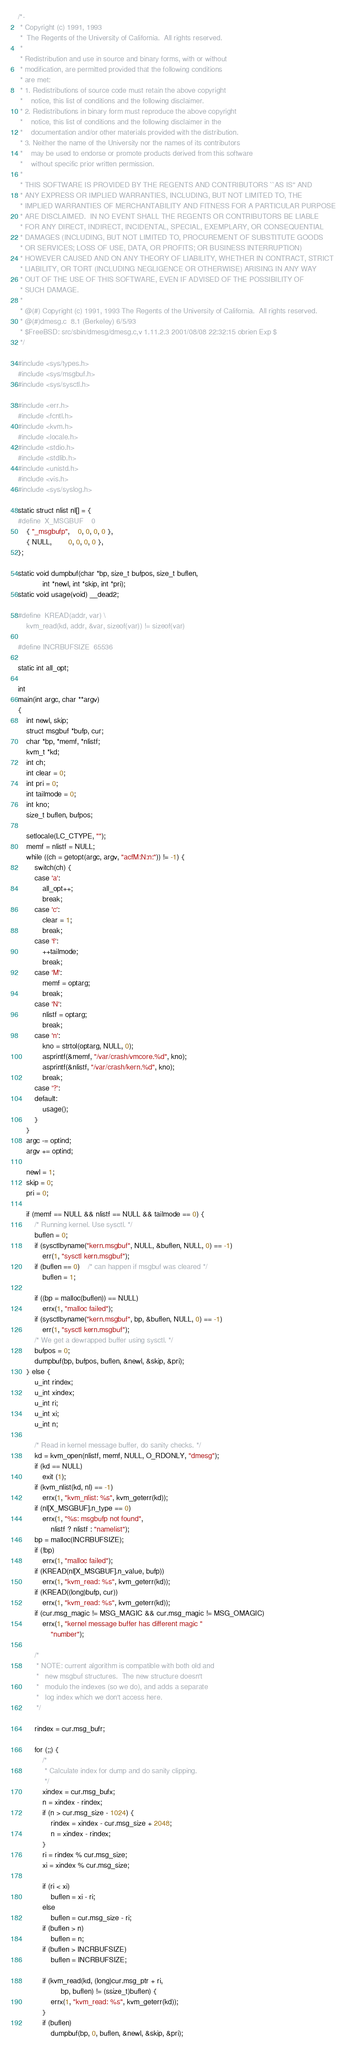<code> <loc_0><loc_0><loc_500><loc_500><_C_>/*-
 * Copyright (c) 1991, 1993
 *	The Regents of the University of California.  All rights reserved.
 *
 * Redistribution and use in source and binary forms, with or without
 * modification, are permitted provided that the following conditions
 * are met:
 * 1. Redistributions of source code must retain the above copyright
 *    notice, this list of conditions and the following disclaimer.
 * 2. Redistributions in binary form must reproduce the above copyright
 *    notice, this list of conditions and the following disclaimer in the
 *    documentation and/or other materials provided with the distribution.
 * 3. Neither the name of the University nor the names of its contributors
 *    may be used to endorse or promote products derived from this software
 *    without specific prior written permission.
 *
 * THIS SOFTWARE IS PROVIDED BY THE REGENTS AND CONTRIBUTORS ``AS IS'' AND
 * ANY EXPRESS OR IMPLIED WARRANTIES, INCLUDING, BUT NOT LIMITED TO, THE
 * IMPLIED WARRANTIES OF MERCHANTABILITY AND FITNESS FOR A PARTICULAR PURPOSE
 * ARE DISCLAIMED.  IN NO EVENT SHALL THE REGENTS OR CONTRIBUTORS BE LIABLE
 * FOR ANY DIRECT, INDIRECT, INCIDENTAL, SPECIAL, EXEMPLARY, OR CONSEQUENTIAL
 * DAMAGES (INCLUDING, BUT NOT LIMITED TO, PROCUREMENT OF SUBSTITUTE GOODS
 * OR SERVICES; LOSS OF USE, DATA, OR PROFITS; OR BUSINESS INTERRUPTION)
 * HOWEVER CAUSED AND ON ANY THEORY OF LIABILITY, WHETHER IN CONTRACT, STRICT
 * LIABILITY, OR TORT (INCLUDING NEGLIGENCE OR OTHERWISE) ARISING IN ANY WAY
 * OUT OF THE USE OF THIS SOFTWARE, EVEN IF ADVISED OF THE POSSIBILITY OF
 * SUCH DAMAGE.
 *
 * @(#) Copyright (c) 1991, 1993 The Regents of the University of California.  All rights reserved.
 * @(#)dmesg.c	8.1 (Berkeley) 6/5/93
 * $FreeBSD: src/sbin/dmesg/dmesg.c,v 1.11.2.3 2001/08/08 22:32:15 obrien Exp $
 */

#include <sys/types.h>
#include <sys/msgbuf.h>
#include <sys/sysctl.h>

#include <err.h>
#include <fcntl.h>
#include <kvm.h>
#include <locale.h>
#include <stdio.h>
#include <stdlib.h>
#include <unistd.h>
#include <vis.h>
#include <sys/syslog.h>

static struct nlist nl[] = {
#define	X_MSGBUF	0
	{ "_msgbufp",	0, 0, 0, 0 },
	{ NULL,		0, 0, 0, 0 },
};

static void dumpbuf(char *bp, size_t bufpos, size_t buflen,
		    int *newl, int *skip, int *pri);
static void usage(void) __dead2;

#define	KREAD(addr, var) \
	kvm_read(kd, addr, &var, sizeof(var)) != sizeof(var)

#define INCRBUFSIZE	65536

static int all_opt;

int
main(int argc, char **argv)
{
	int newl, skip;
	struct msgbuf *bufp, cur;
	char *bp, *memf, *nlistf;
	kvm_t *kd;
	int ch;
	int clear = 0;
	int pri = 0;
	int tailmode = 0;
	int kno;
	size_t buflen, bufpos;

	setlocale(LC_CTYPE, "");
	memf = nlistf = NULL;
	while ((ch = getopt(argc, argv, "acfM:N:n:")) != -1) {
		switch(ch) {
		case 'a':
			all_opt++;
			break;
		case 'c':
			clear = 1;
			break;
		case 'f':
			++tailmode;
			break;
		case 'M':
			memf = optarg;
			break;
		case 'N':
			nlistf = optarg;
			break;
		case 'n':
			kno = strtol(optarg, NULL, 0);
			asprintf(&memf, "/var/crash/vmcore.%d", kno);
			asprintf(&nlistf, "/var/crash/kern.%d", kno);
			break;
		case '?':
		default:
			usage();
		}
	}
	argc -= optind;
	argv += optind;

	newl = 1;
	skip = 0;
	pri = 0;

	if (memf == NULL && nlistf == NULL && tailmode == 0) {
		/* Running kernel. Use sysctl. */
		buflen = 0;
		if (sysctlbyname("kern.msgbuf", NULL, &buflen, NULL, 0) == -1)
			err(1, "sysctl kern.msgbuf");
		if (buflen == 0)	/* can happen if msgbuf was cleared */
			buflen = 1;

		if ((bp = malloc(buflen)) == NULL)
			errx(1, "malloc failed");
		if (sysctlbyname("kern.msgbuf", bp, &buflen, NULL, 0) == -1)
			err(1, "sysctl kern.msgbuf");
		/* We get a dewrapped buffer using sysctl. */
		bufpos = 0;
		dumpbuf(bp, bufpos, buflen, &newl, &skip, &pri);
	} else {
		u_int rindex;
		u_int xindex;
		u_int ri;
		u_int xi;
		u_int n;

		/* Read in kernel message buffer, do sanity checks. */
		kd = kvm_open(nlistf, memf, NULL, O_RDONLY, "dmesg");
		if (kd == NULL)
			exit (1);
		if (kvm_nlist(kd, nl) == -1)
			errx(1, "kvm_nlist: %s", kvm_geterr(kd));
		if (nl[X_MSGBUF].n_type == 0)
			errx(1, "%s: msgbufp not found",
			    nlistf ? nlistf : "namelist");
		bp = malloc(INCRBUFSIZE);
		if (!bp)
			errx(1, "malloc failed");
		if (KREAD(nl[X_MSGBUF].n_value, bufp))
			errx(1, "kvm_read: %s", kvm_geterr(kd));
		if (KREAD((long)bufp, cur))
			errx(1, "kvm_read: %s", kvm_geterr(kd));
		if (cur.msg_magic != MSG_MAGIC && cur.msg_magic != MSG_OMAGIC)
			errx(1, "kernel message buffer has different magic "
			    "number");

		/*
		 * NOTE: current algorithm is compatible with both old and
		 *	 new msgbuf structures.  The new structure doesn't
		 *	 modulo the indexes (so we do), and adds a separate
		 *	 log index which we don't access here.
		 */

		rindex = cur.msg_bufr;

		for (;;) {
			/*
			 * Calculate index for dump and do sanity clipping.
			 */
			xindex = cur.msg_bufx;
			n = xindex - rindex;
			if (n > cur.msg_size - 1024) {
				rindex = xindex - cur.msg_size + 2048;
				n = xindex - rindex;
			}
			ri = rindex % cur.msg_size;
			xi = xindex % cur.msg_size;

			if (ri < xi)
				buflen = xi - ri;
			else
				buflen = cur.msg_size - ri;
			if (buflen > n)
				buflen = n;
			if (buflen > INCRBUFSIZE)
				buflen = INCRBUFSIZE;

			if (kvm_read(kd, (long)cur.msg_ptr + ri,
				     bp, buflen) != (ssize_t)buflen) {
				errx(1, "kvm_read: %s", kvm_geterr(kd));
			}
			if (buflen)
				dumpbuf(bp, 0, buflen, &newl, &skip, &pri);</code> 